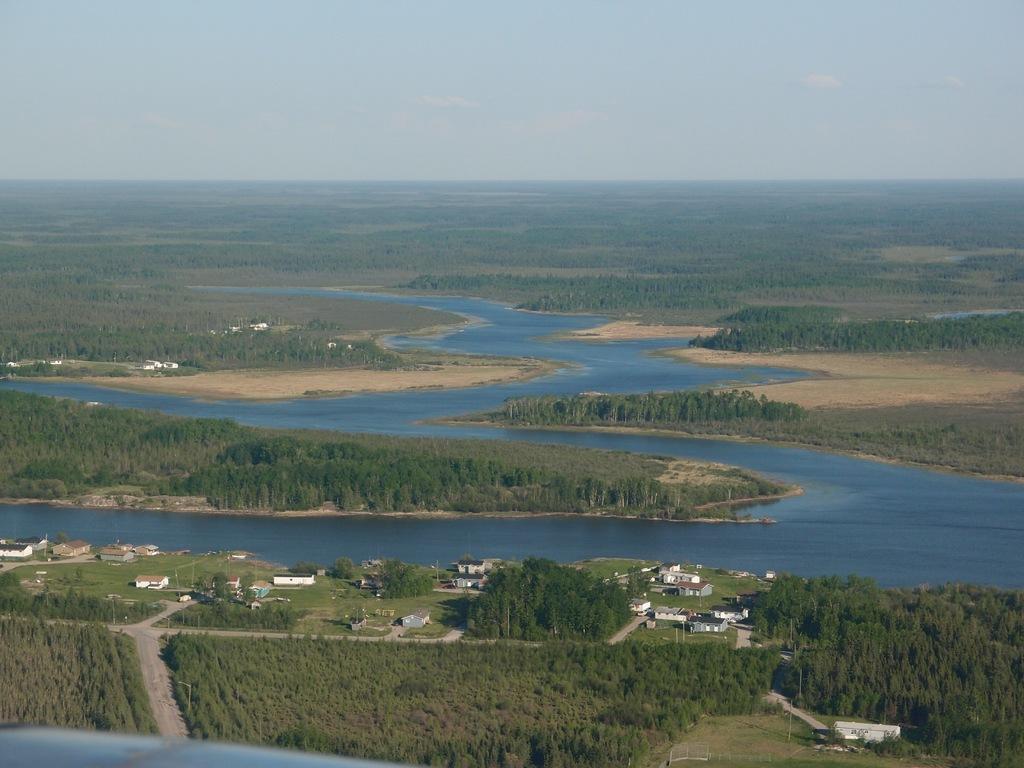Could you give a brief overview of what you see in this image? In this picture, we can see a few buildings, trees, poles, water, and we can see the sky with clouds. 